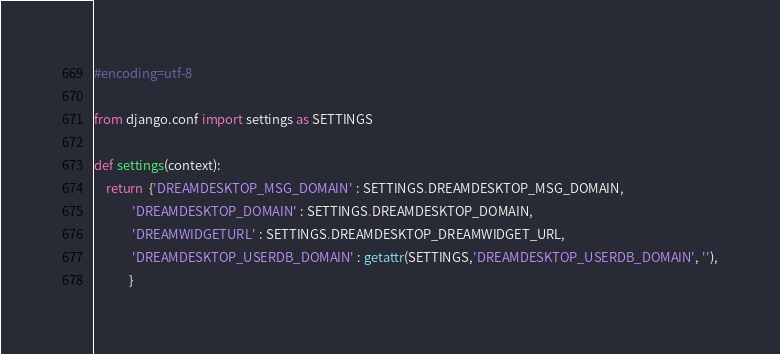<code> <loc_0><loc_0><loc_500><loc_500><_Python_>
#encoding=utf-8

from django.conf import settings as SETTINGS

def settings(context):
    return  {'DREAMDESKTOP_MSG_DOMAIN' : SETTINGS.DREAMDESKTOP_MSG_DOMAIN,
             'DREAMDESKTOP_DOMAIN' : SETTINGS.DREAMDESKTOP_DOMAIN,
             'DREAMWIDGETURL' : SETTINGS.DREAMDESKTOP_DREAMWIDGET_URL,
             'DREAMDESKTOP_USERDB_DOMAIN' : getattr(SETTINGS,'DREAMDESKTOP_USERDB_DOMAIN', ''),
            }
</code> 